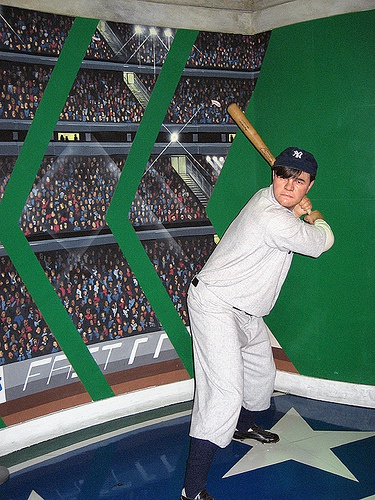Describe the objects in this image and their specific colors. I can see people in gray, lightgray, black, darkgray, and navy tones and baseball bat in gray, tan, and olive tones in this image. 